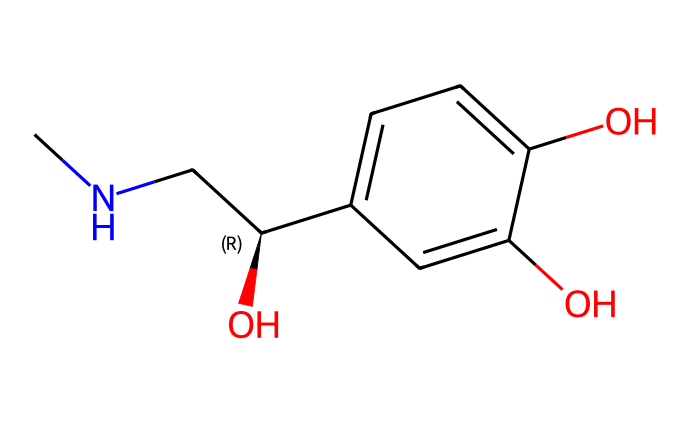What is the molecular formula of adrenaline? The molecular structure consists of carbon (C), hydrogen (H), nitrogen (N), and oxygen (O) atoms. Counting the atoms from the SMILES representation gives C9H13NO3.
Answer: C9H13NO3 How many hydroxyl groups are present in the structure? By examining the SMILES notation, we can identify that there are two 'O' atoms that are connected to hydrogen (hydroxyl) groups in the aromatic ring.
Answer: 3 What type of functional groups are present in this molecule? The structure shows hydroxyl (-OH) groups, an amine (-NH), and a secondary alcohol (the carbon with -OH and -C) in its structure. These functional groups characterize adrenaline.
Answer: hydroxyl and amine Is adrenaline a primary, secondary, or tertiary amine? The nitrogen is bonded to two carbon atoms and one hydrogen atom according to the structure, which classifies it as a secondary amine.
Answer: secondary How many rings are visible in the structure? The chemical structure contains one aromatic ring formed by the six carbon atoms in a cyclic arrangement, which is indicative of phenolic structures.
Answer: 1 What is the characteristic of adrenaline that affects its solubility? The presence of multiple hydroxyl groups increases the molecule's polarity, which enhances its solubility in water. Hence, adrenaline is soluble in aqueous solutions due to these polar functional groups.
Answer: polar 